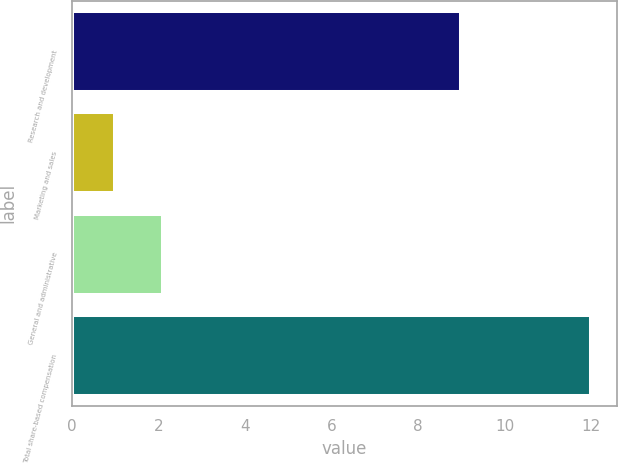<chart> <loc_0><loc_0><loc_500><loc_500><bar_chart><fcel>Research and development<fcel>Marketing and sales<fcel>General and administrative<fcel>Total share-based compensation<nl><fcel>9<fcel>1<fcel>2.1<fcel>12<nl></chart> 